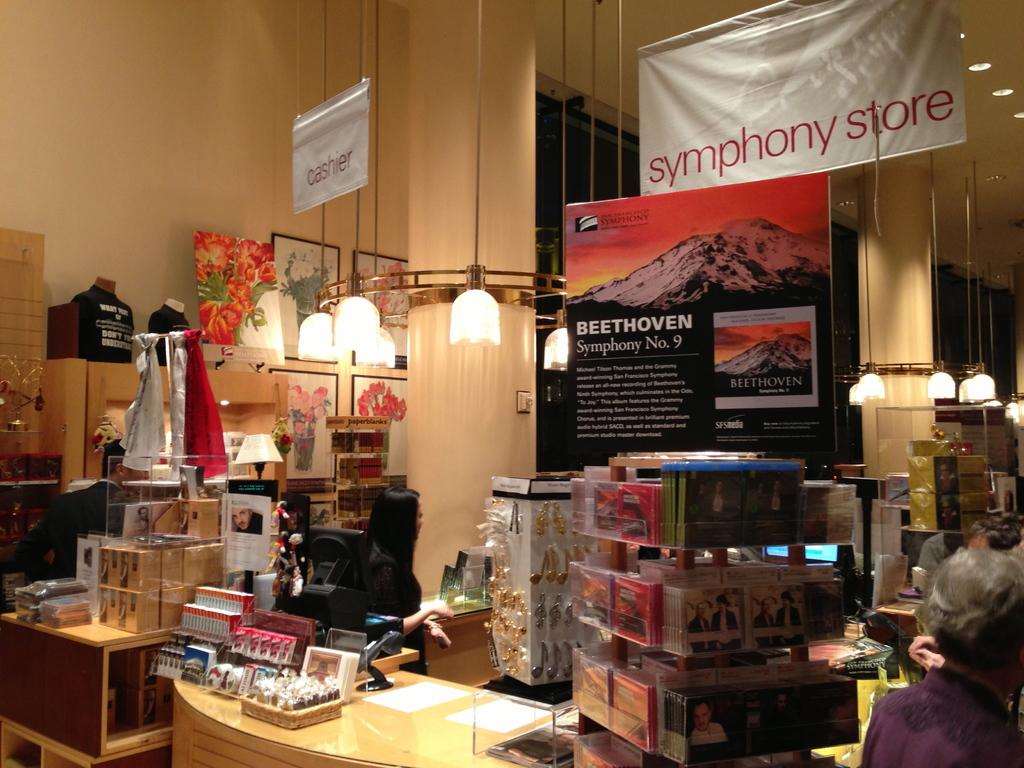<image>
Render a clear and concise summary of the photo. A number of products are below a sign that says Symphony store. 